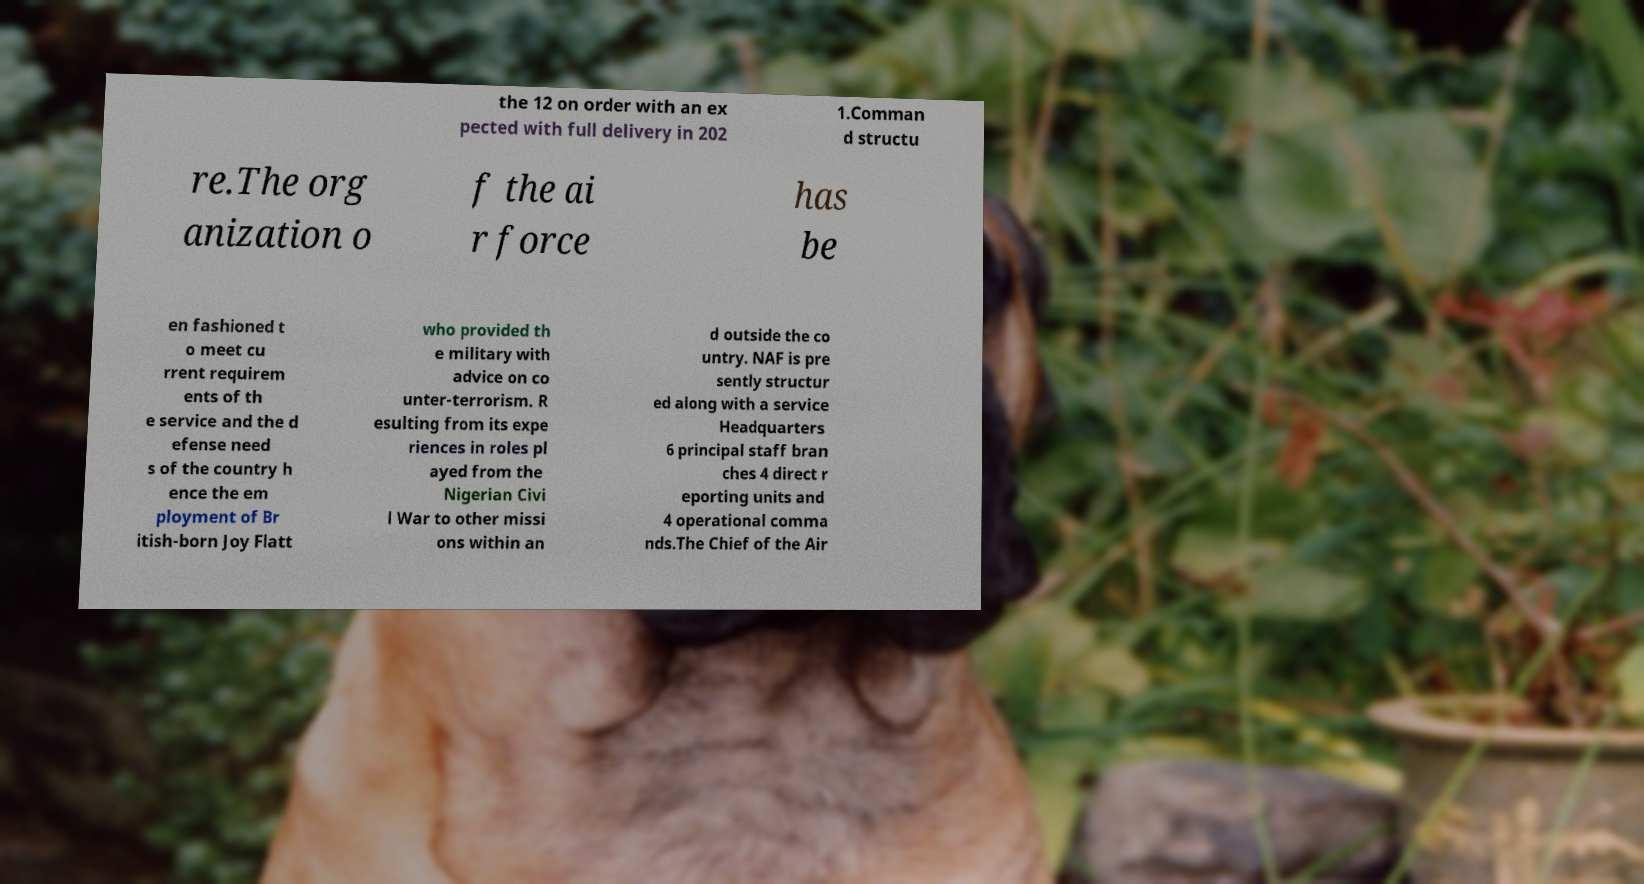There's text embedded in this image that I need extracted. Can you transcribe it verbatim? the 12 on order with an ex pected with full delivery in 202 1.Comman d structu re.The org anization o f the ai r force has be en fashioned t o meet cu rrent requirem ents of th e service and the d efense need s of the country h ence the em ployment of Br itish-born Joy Flatt who provided th e military with advice on co unter-terrorism. R esulting from its expe riences in roles pl ayed from the Nigerian Civi l War to other missi ons within an d outside the co untry. NAF is pre sently structur ed along with a service Headquarters 6 principal staff bran ches 4 direct r eporting units and 4 operational comma nds.The Chief of the Air 